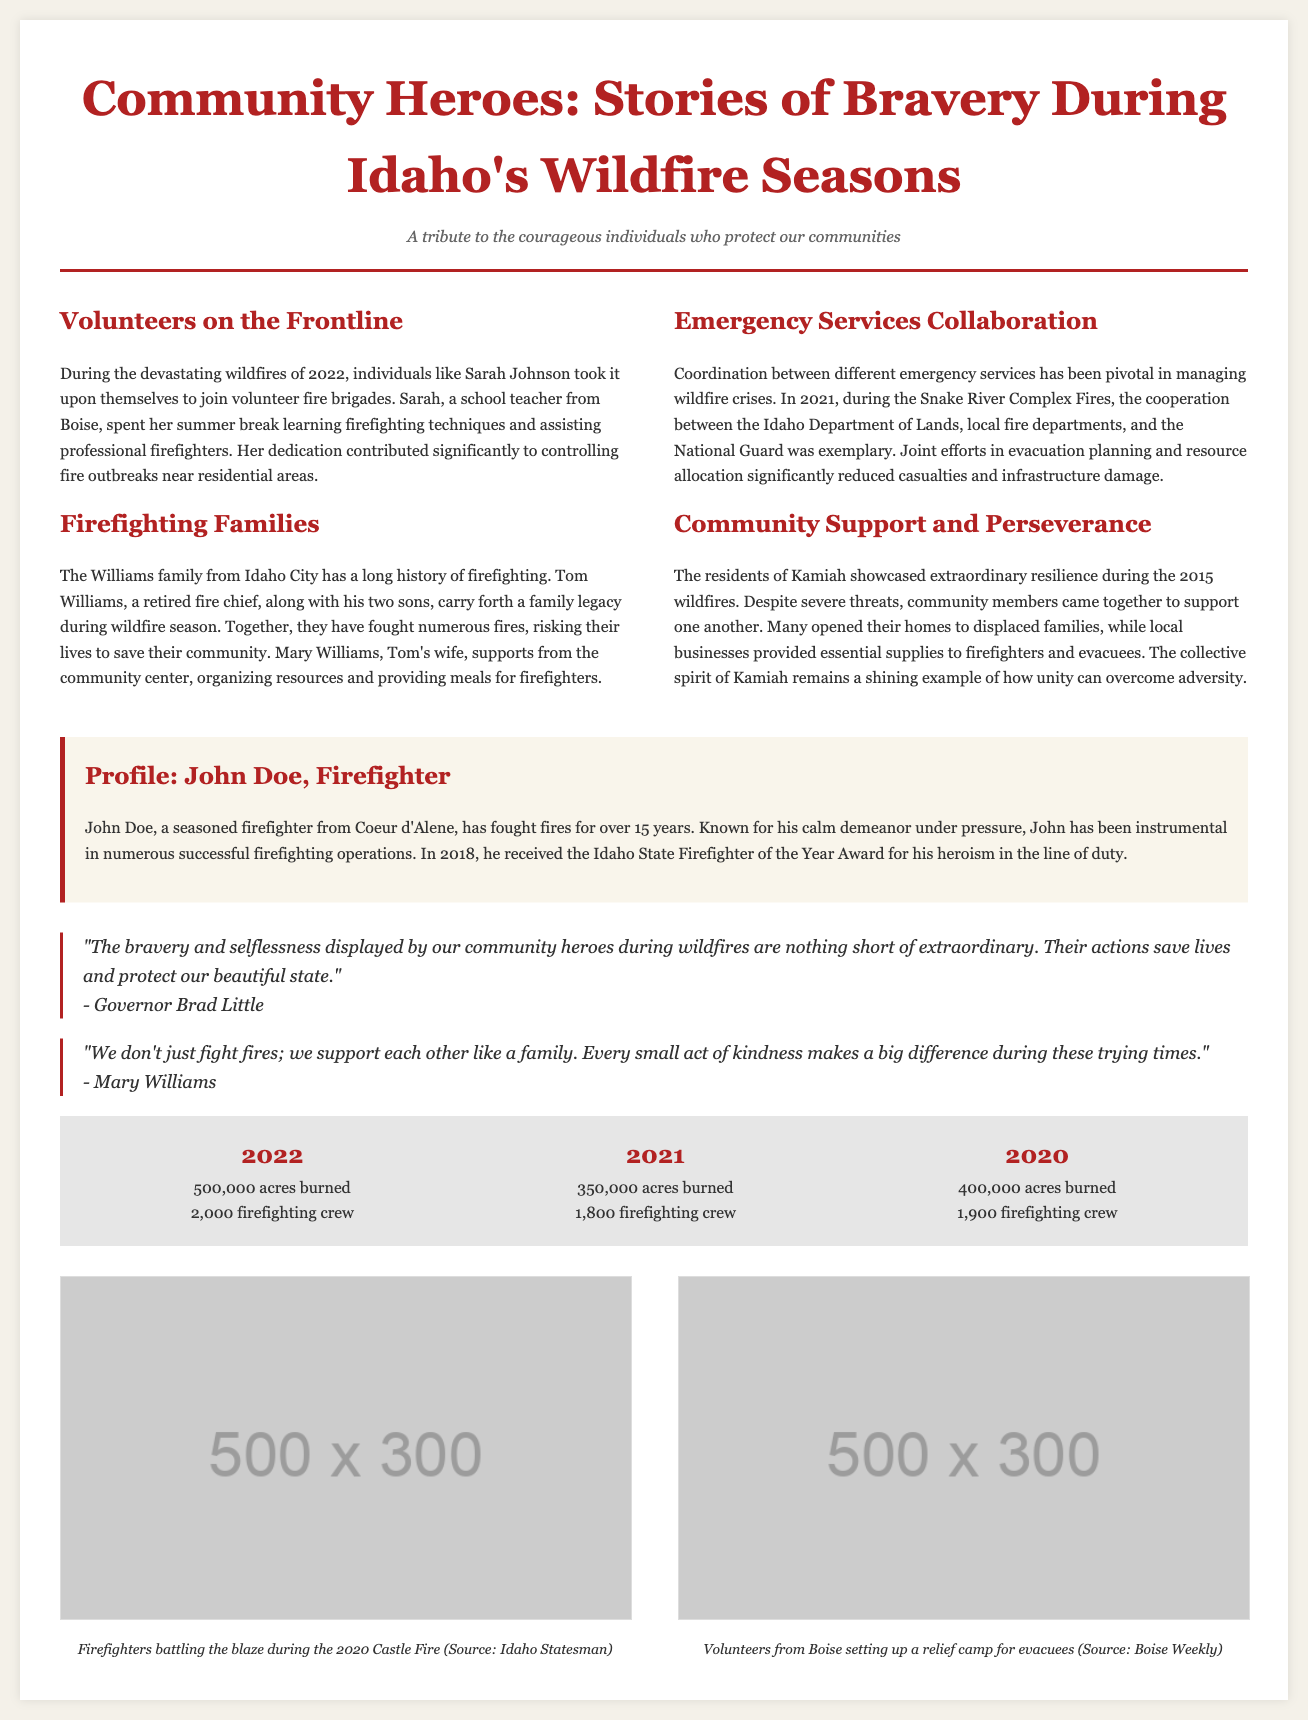What is the title of the document? The title is prominently displayed at the top of the document, stating the focus of the article.
Answer: Community Heroes: Stories of Bravery During Idaho's Wildfire Seasons Who is the volunteer mentioned in the document? The document specifically names Sarah Johnson as a volunteer who helped during the wildfires.
Answer: Sarah Johnson Which family is highlighted for their firefighting legacy? The Williams family is mentioned in connection to their long history of firefighting in Idaho.
Answer: Williams family What year did 500,000 acres burn? The statistics section of the document lists the area burned for each year, clearly denoting the year when the area was 500,000 acres.
Answer: 2022 Who received the Idaho State Firefighter of the Year Award in 2018? The document includes a profile that states John Doe received this award for his heroism.
Answer: John Doe What was the role of Mary Williams during the wildfires? The document describes Mary Williams' roles related to supporting firefighters from the community center.
Answer: Organizing resources In which city did John Doe work as a firefighter? The document specifically states that John Doe is from Coeur d'Alene, where he has worked as a firefighter.
Answer: Coeur d'Alene What is one action taken by the residents of Kamiah during the wildfires? The document highlights that community members supported one another and opened their homes to displaced families.
Answer: Opened their homes Which year had the lowest number of acres burned in the statistics? The statistics in the document identify the year with the least acreage burned.
Answer: 2021 